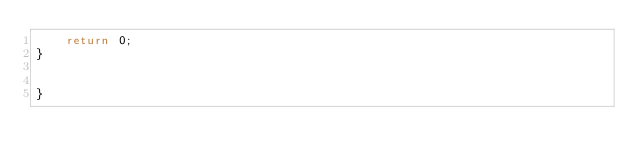Convert code to text. <code><loc_0><loc_0><loc_500><loc_500><_C++_>    return 0;
}


}
</code> 